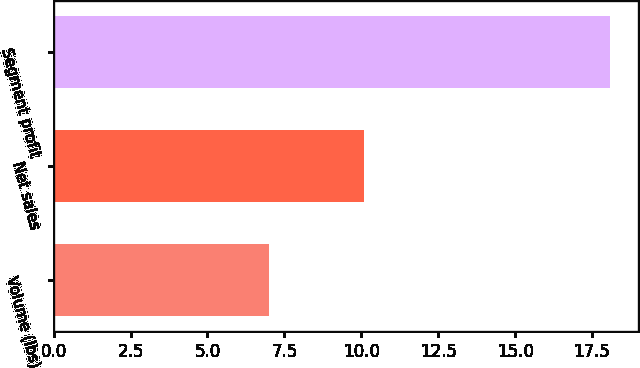Convert chart to OTSL. <chart><loc_0><loc_0><loc_500><loc_500><bar_chart><fcel>Volume (lbs)<fcel>Net sales<fcel>Segment profit<nl><fcel>7<fcel>10.1<fcel>18.1<nl></chart> 